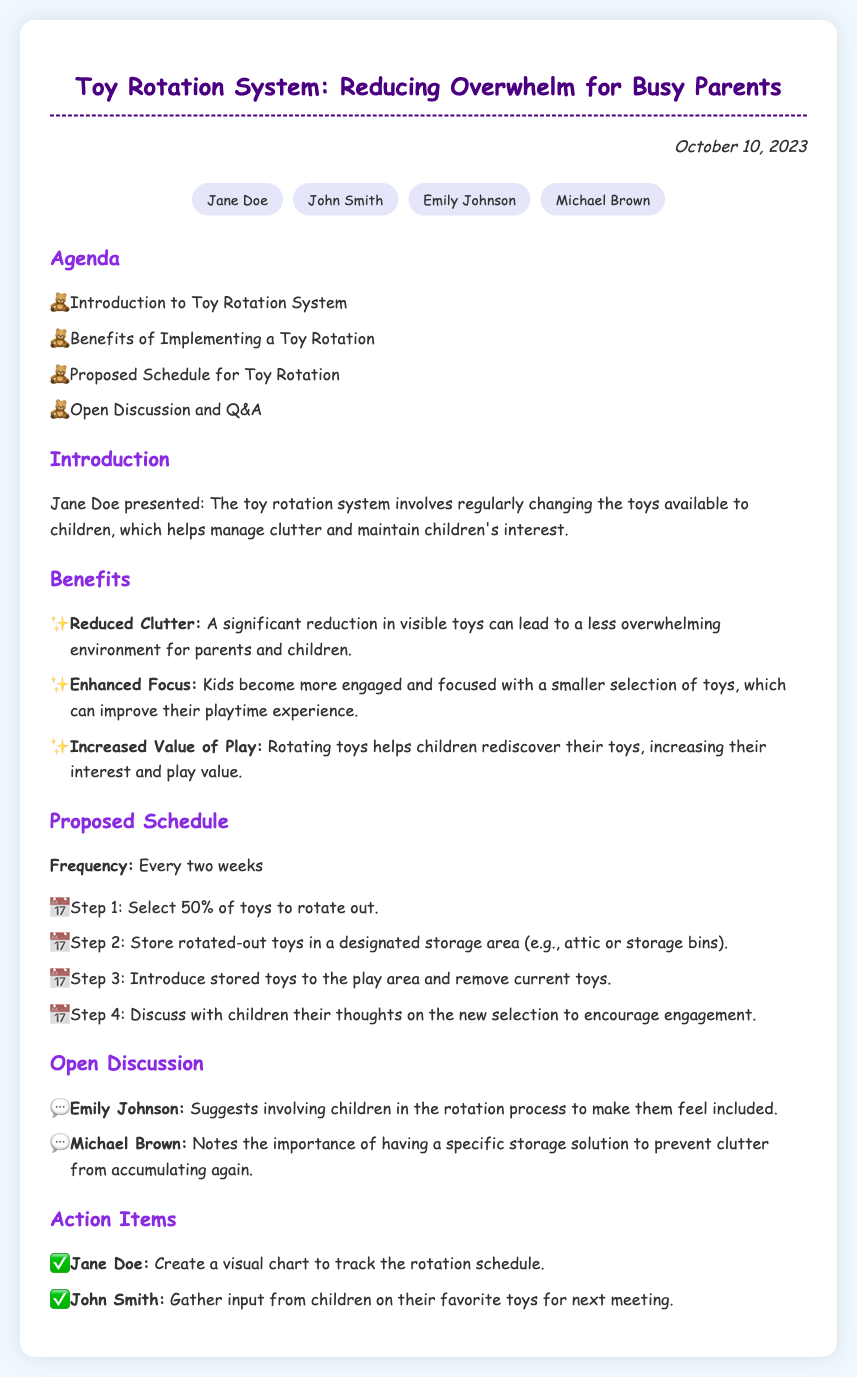What is the date of the meeting? The date of the meeting is explicitly mentioned at the top of the document.
Answer: October 10, 2023 Who presented the introduction to the Toy Rotation System? Jane Doe is identified as the person who presented the introduction in the document.
Answer: Jane Doe What is the frequency of the toy rotation? The proposed frequency of the toy rotation is specified in the schedule section.
Answer: Every two weeks What is one benefit of implementing a toy rotation system? The benefits are listed in a dedicated section, describing multiple advantages.
Answer: Reduced Clutter Which attendee suggested involving children in the rotation process? Emily Johnson's suggestion is highlighted during the open discussion section.
Answer: Emily Johnson What is one action item assigned to John Smith? The action items list identifies responsibilities assigned to attendees.
Answer: Gather input from children on their favorite toys for next meeting What is the designated storage area for rotated-out toys? The schedule provides a specific example of where to store rotated toys.
Answer: Attic or storage bins What type of chart will Jane Doe create? The action items section specifies the type of chart related to the rotation schedule.
Answer: Visual chart 